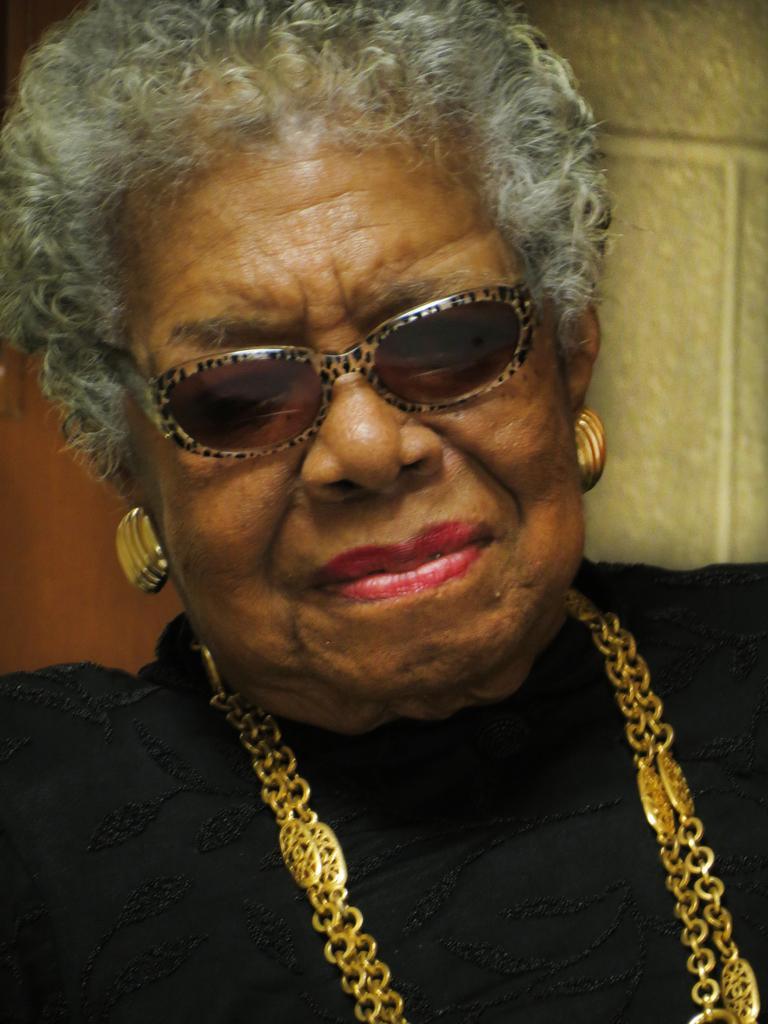Describe this image in one or two sentences. In the image in the center we can see one woman wearing a gold chain,gold earrings and sun glasses. In the background there is a wall. 